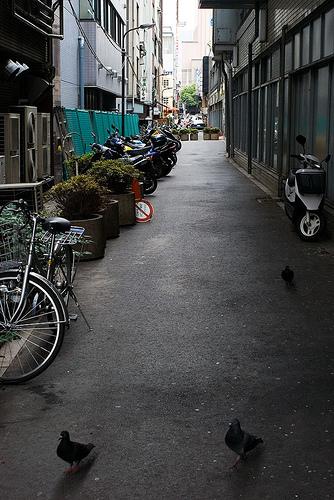How many bikes are shown?
Quick response, please. 1. What kind of animals are shown?
Answer briefly. Pigeons. How many birds are on the ground?
Be succinct. 3. 